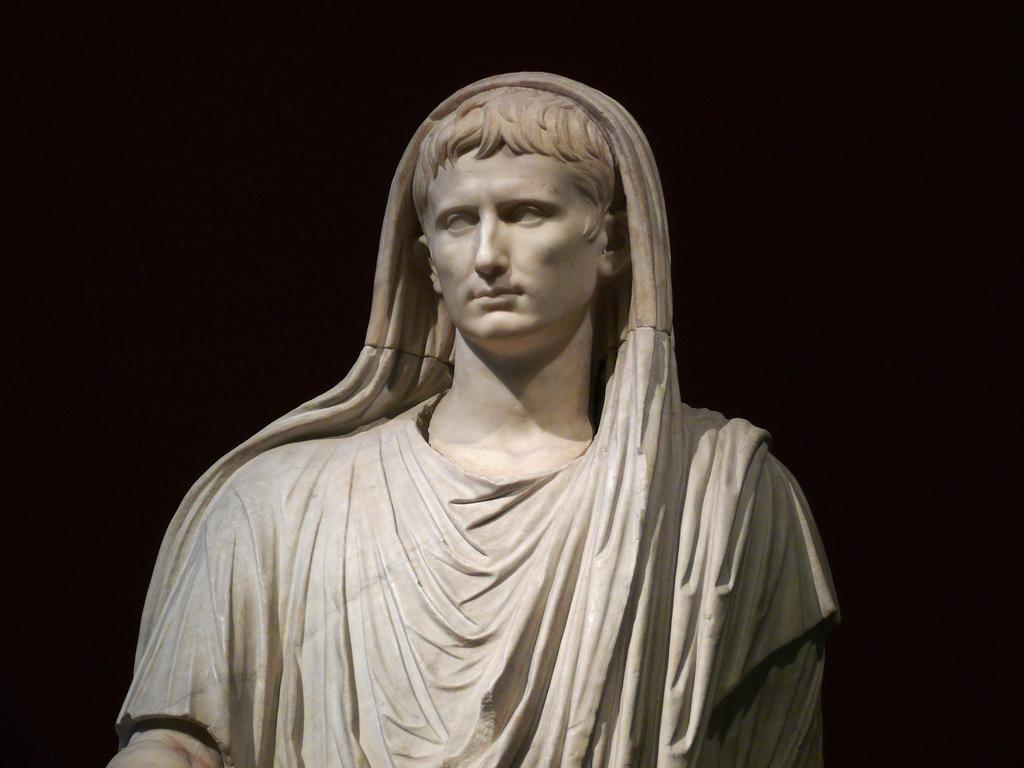Can you describe this image briefly? In this image I can see a white colour sculpture of a woman in the front. I can also see black color in the background. 